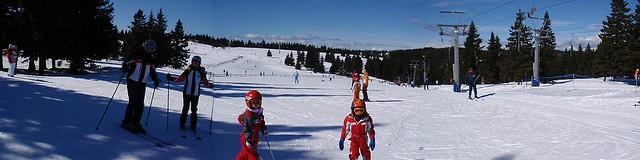What are the metal towers used for? Please explain your reasoning. transportation. The metal towers are used for transporting people on the slope. 